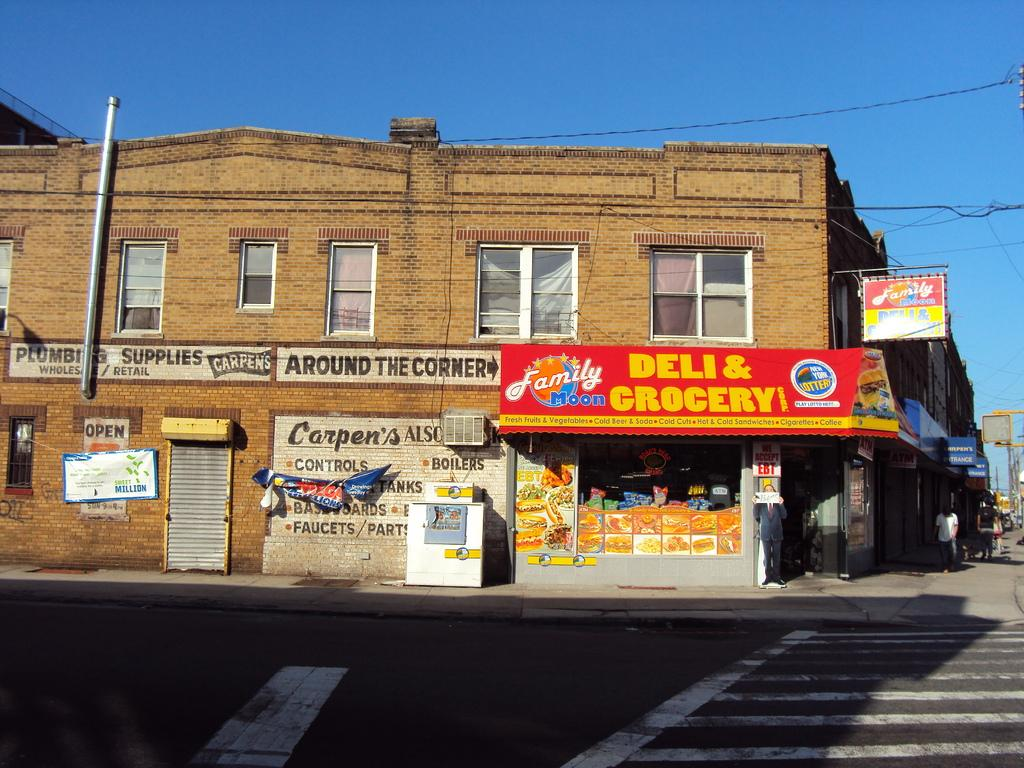What type of structure is visible in the image? There is a building in the image. What objects are present near the building? There are boards, banners, and cables visible in the image. Who is present in the image? There is a group of people in the image. What is the purpose of the banners in the image? The purpose of the banners cannot be determined from the image alone. What type of cooling system is visible in the image? There is an air conditioner in the image. What type of surface can be seen in the image? There is a road in the image. What is visible in the background of the image? The sky is visible in the background of the image. What type of cheese is being used to write on the boards in the image? There is no cheese present in the image, and the boards do not appear to have any writing on them. 